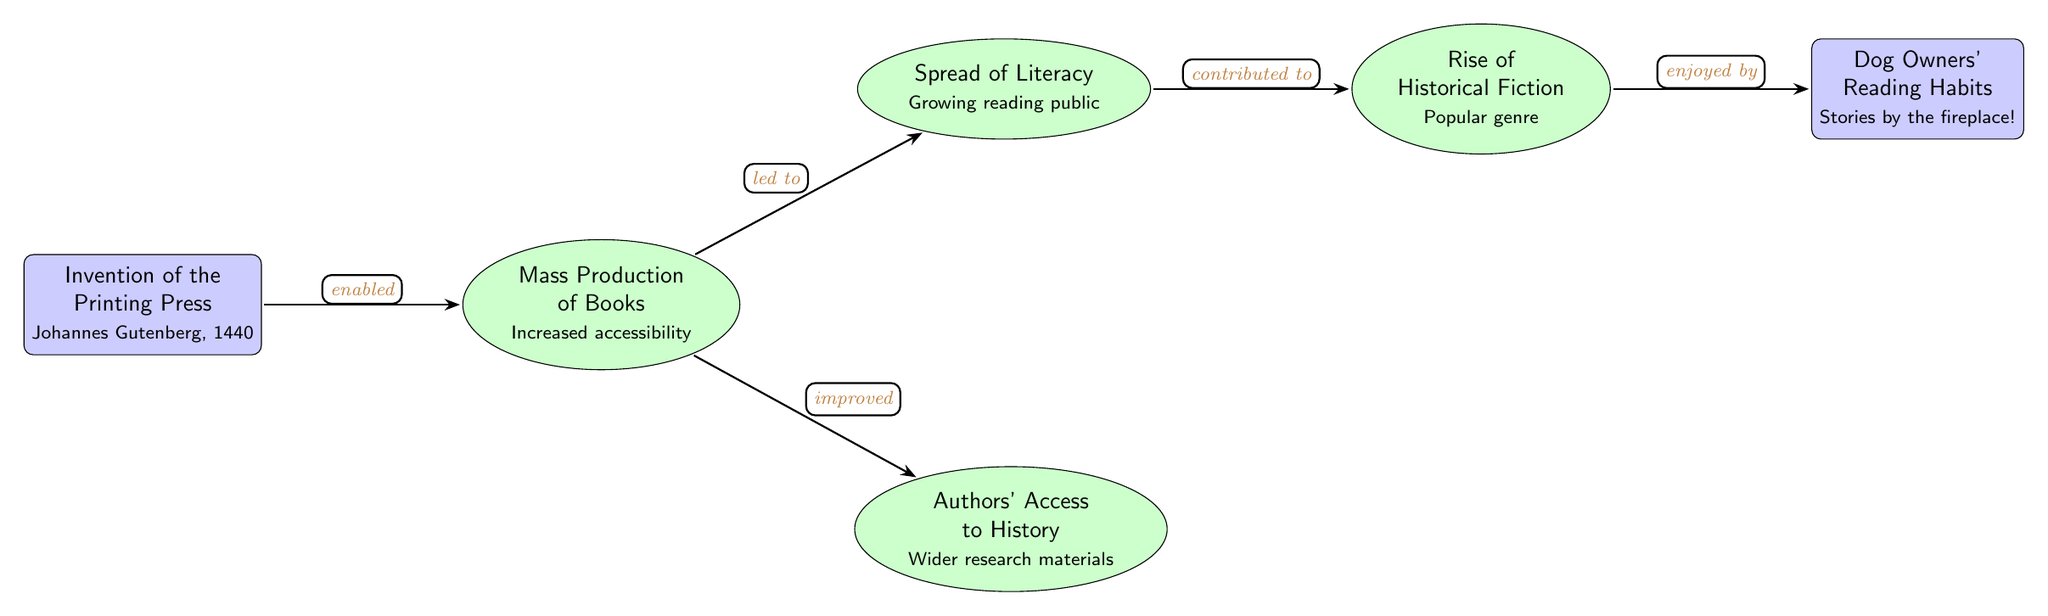What is the first event in the diagram? The first event listed in the diagram is the invention of the printing press by Johannes Gutenberg in 1440. This is depicted at the leftmost node and is described in the event rectangle.
Answer: Invention of the Printing Press How many effects stem from the mass production of books? There are two effects that stem from the mass production of books: the spread of literacy and authors' access to history. Each effect is represented by an ellipse connected to the mass production of books node.
Answer: Two effects What does the spread of literacy contribute to? The spread of literacy contributes to the rise of historical fiction, as indicated by the arrow connecting the literacy node to the historical fiction node, with the label "contributed to."
Answer: Rise of Historical Fiction What type of literature became popular as a result of increased literacy? The type of literature that became popular as a result of increased literacy is historical fiction. This is shown as the effect of the literacy node leading to the historical fiction node in the diagram.
Answer: Historical Fiction How are dog owners related to the rise of historical fiction? Dog owners are related to the rise of historical fiction through their reading habits, which are depicted as enjoying stories by the fireplace, suggesting a connection between personal interests and literature preferences.
Answer: Enjoyed by What does improved author access to research materials imply? Improved author access to research materials implies that authors could utilize a wider variety of sources for their writing, enhancing the depth and quality of historical fiction. This is captured in the diagram through the connection from the books node to the authors node, with the label "improved."
Answer: Wider research materials How many nodes are related to the effects of the printing press? There are four effect nodes related to the printing press: mass production of books, spread of literacy, authors' access to history, and rise of historical fiction. Each of these effects is directly connected to at least one other node, forming a network of implications stemming from the invention of the printing press.
Answer: Four nodes What enabled the mass production of books? The invention of the printing press enabled the mass production of books, as indicated by the directional arrow labeled "enabled" that flows from the press event node to the books effect node.
Answer: Invention of the Printing Press 